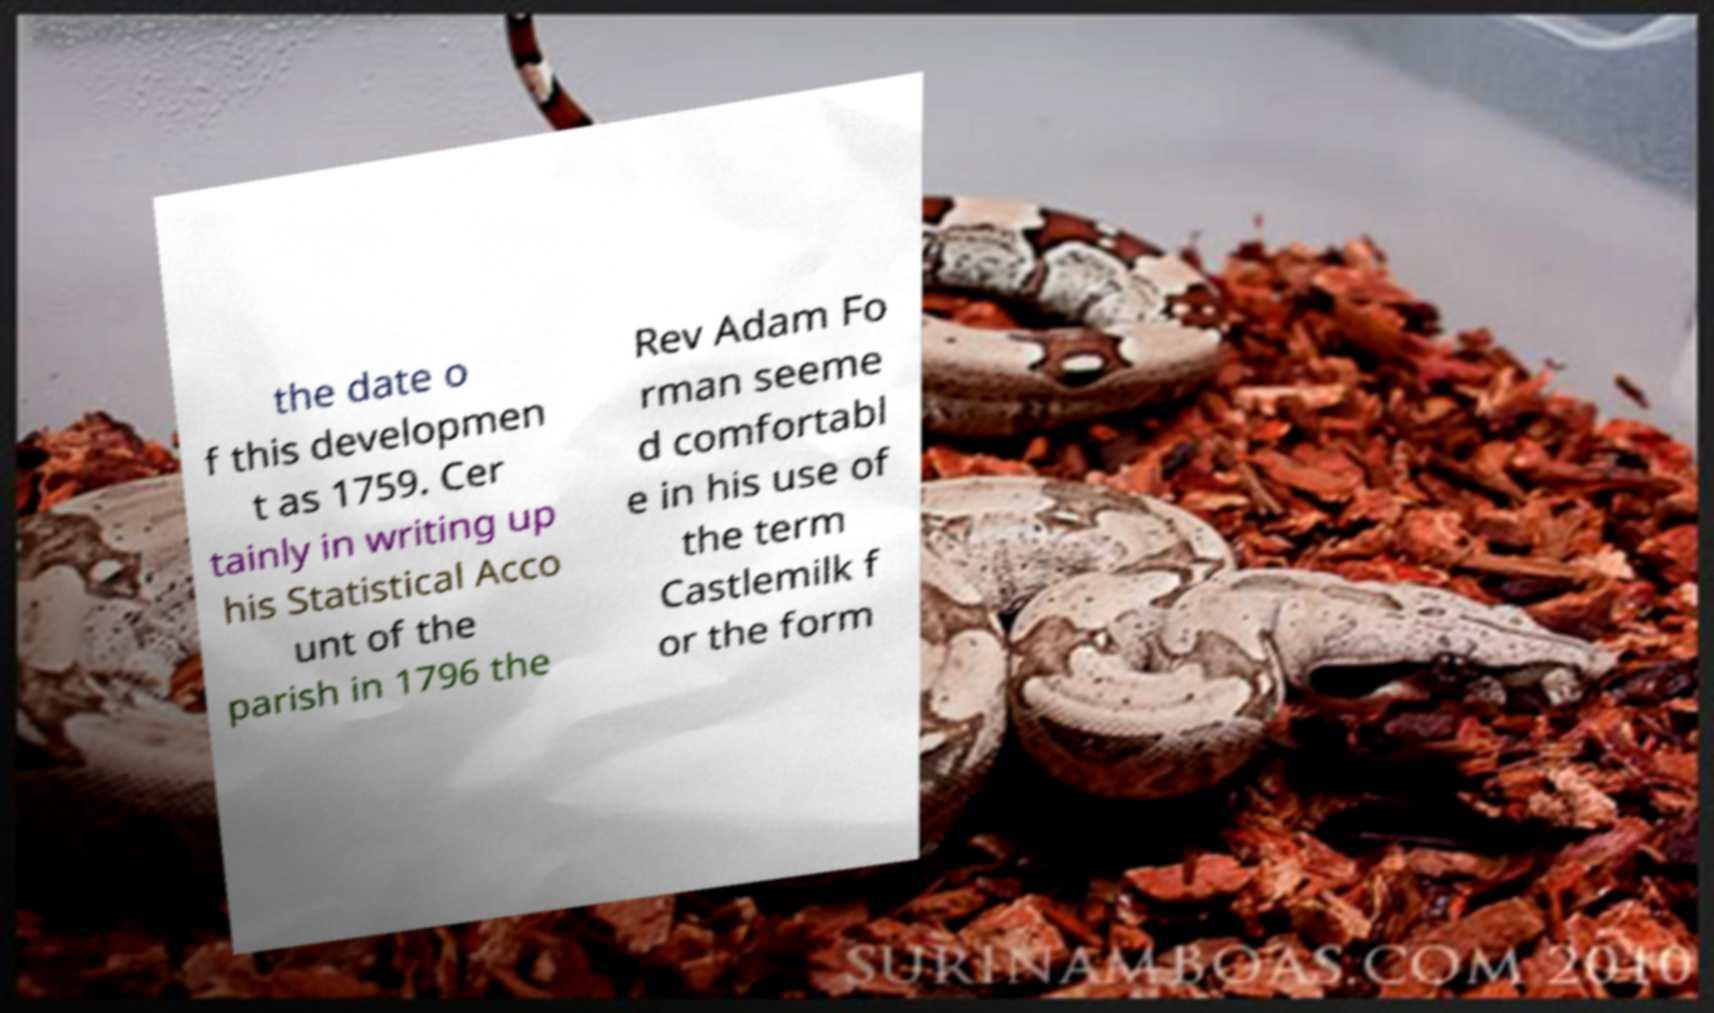Could you extract and type out the text from this image? the date o f this developmen t as 1759. Cer tainly in writing up his Statistical Acco unt of the parish in 1796 the Rev Adam Fo rman seeme d comfortabl e in his use of the term Castlemilk f or the form 